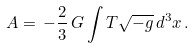<formula> <loc_0><loc_0><loc_500><loc_500>A = \, - \frac { 2 } { 3 } \, G \int T \sqrt { - g } \, d ^ { 3 } x \, .</formula> 